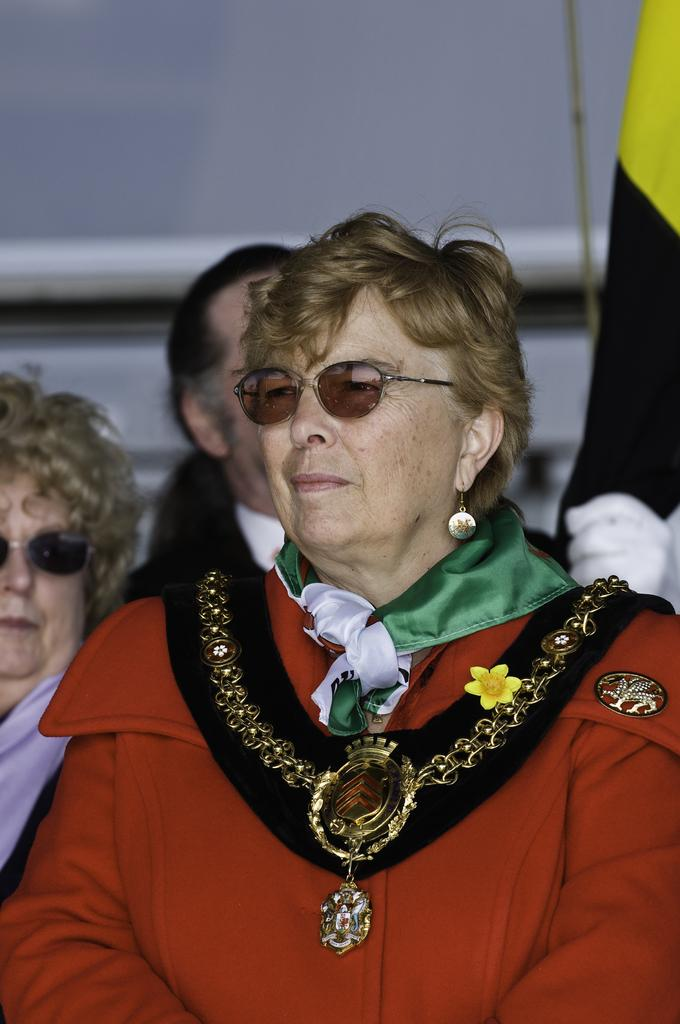Who or what can be seen in the image? There are people in the image. What are the people doing in the image? The people are sitting on chairs. What type of underwear is the person on the left wearing in the image? There is no information about underwear in the image, as it only shows people sitting on chairs. 